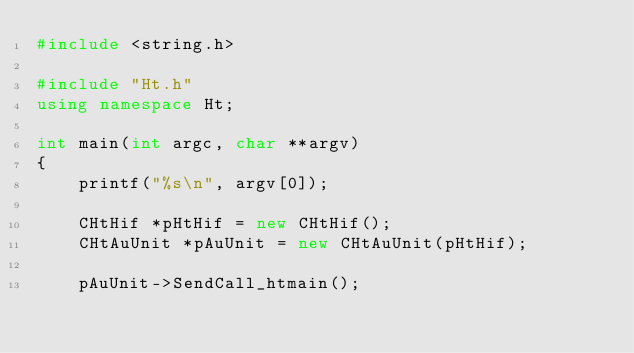Convert code to text. <code><loc_0><loc_0><loc_500><loc_500><_C++_>#include <string.h>

#include "Ht.h"
using namespace Ht;

int main(int argc, char **argv)
{
	printf("%s\n", argv[0]);

	CHtHif *pHtHif = new CHtHif();
	CHtAuUnit *pAuUnit = new CHtAuUnit(pHtHif);

	pAuUnit->SendCall_htmain();
</code> 